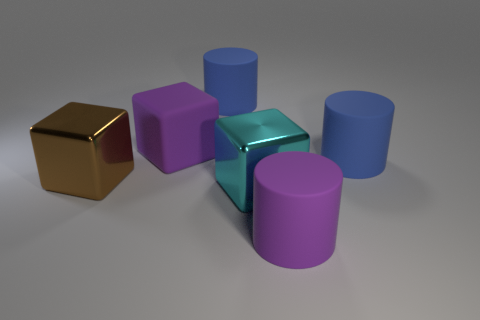Add 1 cyan cubes. How many objects exist? 7 Add 2 cyan metallic cubes. How many cyan metallic cubes are left? 3 Add 3 brown shiny objects. How many brown shiny objects exist? 4 Subtract 0 green cubes. How many objects are left? 6 Subtract all blue matte cylinders. Subtract all large cyan shiny blocks. How many objects are left? 3 